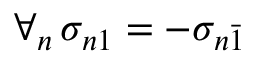<formula> <loc_0><loc_0><loc_500><loc_500>\forall _ { n } \, \sigma _ { n 1 } = - \sigma _ { n \bar { 1 } }</formula> 